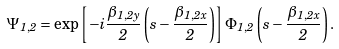Convert formula to latex. <formula><loc_0><loc_0><loc_500><loc_500>\Psi _ { 1 , 2 } = \exp \left [ - i \frac { { \beta } _ { 1 , 2 y } } { 2 } \left ( s - \frac { { \beta } _ { 1 , 2 x } } { 2 } \right ) \right ] \Phi _ { 1 , 2 } \left ( s - \frac { { \beta } _ { 1 , 2 x } } { 2 } \right ) .</formula> 